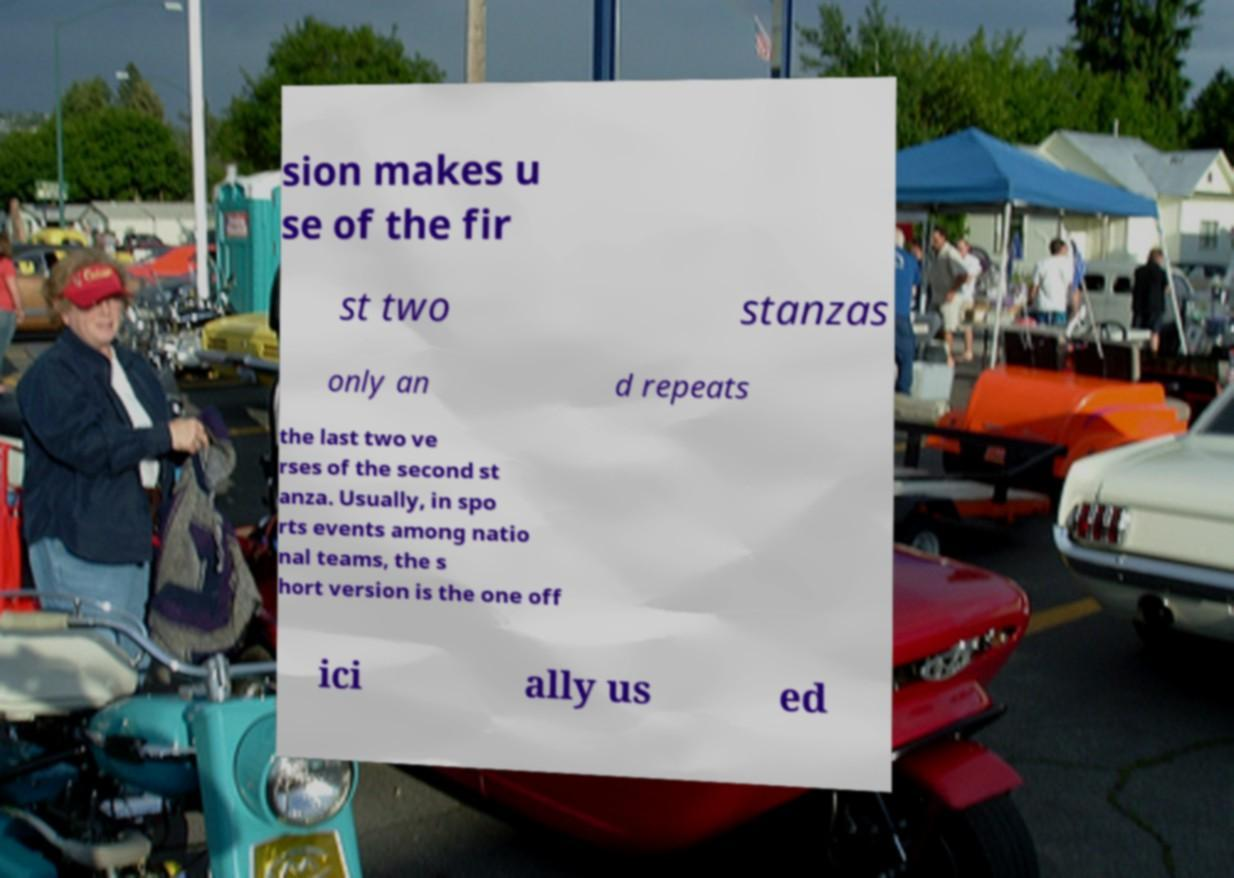What messages or text are displayed in this image? I need them in a readable, typed format. sion makes u se of the fir st two stanzas only an d repeats the last two ve rses of the second st anza. Usually, in spo rts events among natio nal teams, the s hort version is the one off ici ally us ed 